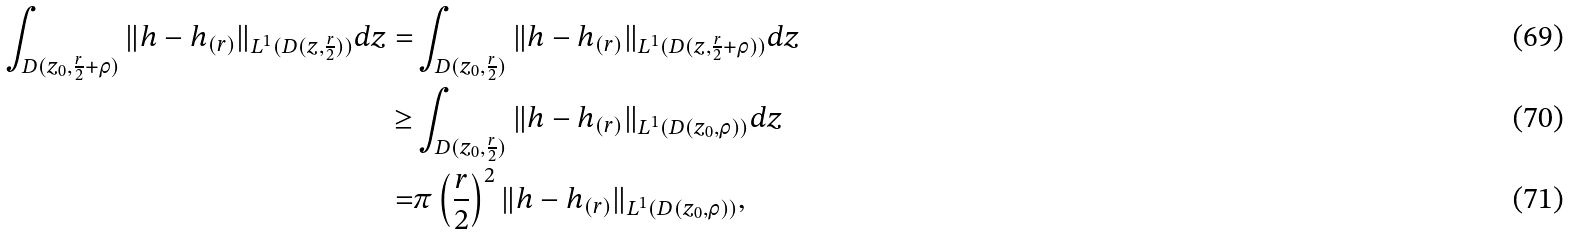Convert formula to latex. <formula><loc_0><loc_0><loc_500><loc_500>\int _ { D ( z _ { 0 } , \frac { r } { 2 } + \rho ) } \| h - h _ { ( r ) } \| _ { L ^ { 1 } ( D ( z , \frac { r } { 2 } ) ) } d z = & \int _ { D ( z _ { 0 } , \frac { r } { 2 } ) } \| h - h _ { ( r ) } \| _ { L ^ { 1 } ( D ( z , \frac { r } { 2 } + \rho ) ) } d z \\ \geq & \int _ { D ( z _ { 0 } , \frac { r } { 2 } ) } \| h - h _ { ( r ) } \| _ { L ^ { 1 } ( D ( z _ { 0 } , \rho ) ) } d z \\ = & \pi \left ( \frac { r } { 2 } \right ) ^ { 2 } \| h - h _ { ( r ) } \| _ { L ^ { 1 } ( D ( z _ { 0 } , \rho ) ) } ,</formula> 